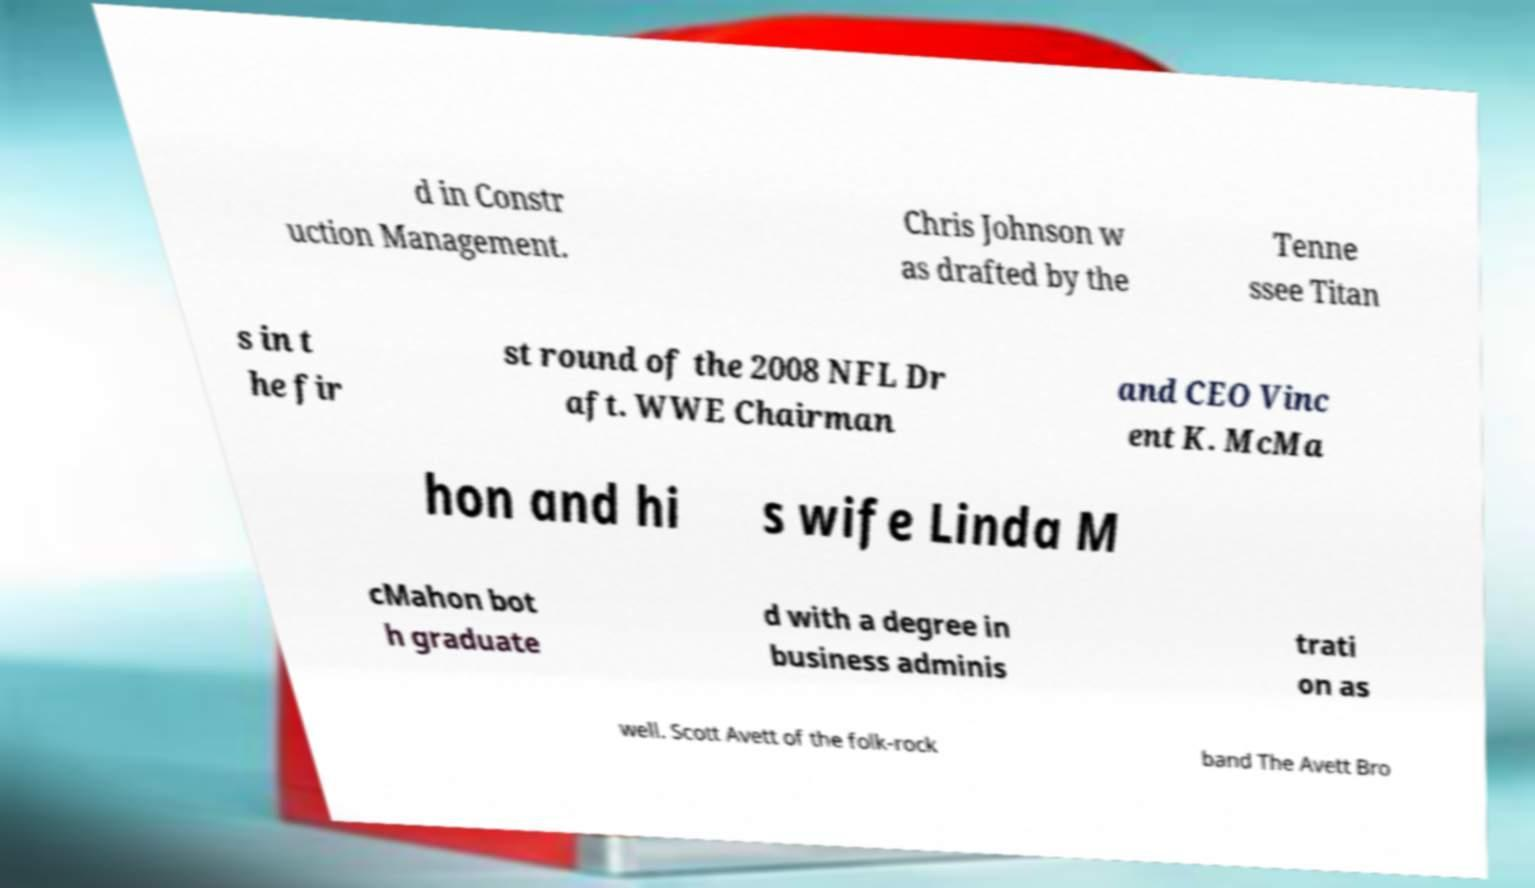What messages or text are displayed in this image? I need them in a readable, typed format. d in Constr uction Management. Chris Johnson w as drafted by the Tenne ssee Titan s in t he fir st round of the 2008 NFL Dr aft. WWE Chairman and CEO Vinc ent K. McMa hon and hi s wife Linda M cMahon bot h graduate d with a degree in business adminis trati on as well. Scott Avett of the folk-rock band The Avett Bro 